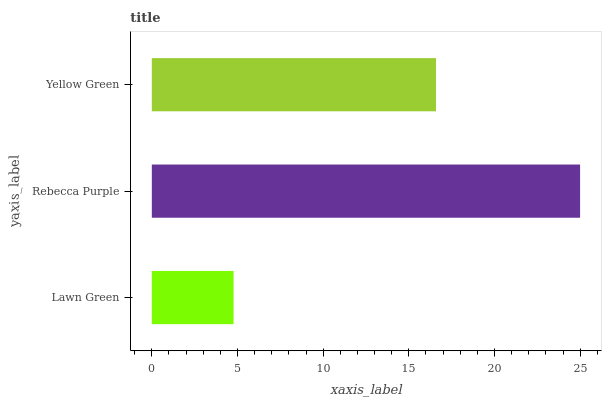Is Lawn Green the minimum?
Answer yes or no. Yes. Is Rebecca Purple the maximum?
Answer yes or no. Yes. Is Yellow Green the minimum?
Answer yes or no. No. Is Yellow Green the maximum?
Answer yes or no. No. Is Rebecca Purple greater than Yellow Green?
Answer yes or no. Yes. Is Yellow Green less than Rebecca Purple?
Answer yes or no. Yes. Is Yellow Green greater than Rebecca Purple?
Answer yes or no. No. Is Rebecca Purple less than Yellow Green?
Answer yes or no. No. Is Yellow Green the high median?
Answer yes or no. Yes. Is Yellow Green the low median?
Answer yes or no. Yes. Is Lawn Green the high median?
Answer yes or no. No. Is Rebecca Purple the low median?
Answer yes or no. No. 